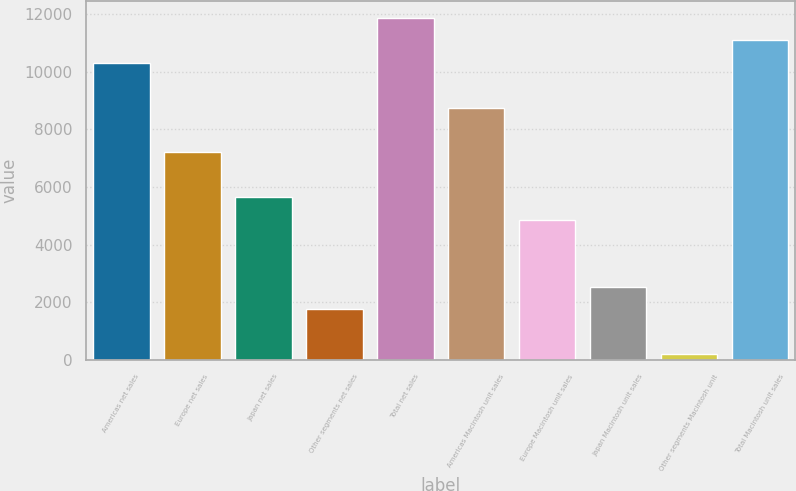<chart> <loc_0><loc_0><loc_500><loc_500><bar_chart><fcel>Americas net sales<fcel>Europe net sales<fcel>Japan net sales<fcel>Other segments net sales<fcel>Total net sales<fcel>Americas Macintosh unit sales<fcel>Europe Macintosh unit sales<fcel>Japan Macintosh unit sales<fcel>Other segments Macintosh unit<fcel>Total Macintosh unit sales<nl><fcel>10314.6<fcel>7205.8<fcel>5651.4<fcel>1765.4<fcel>11869<fcel>8760.2<fcel>4874.2<fcel>2542.6<fcel>211<fcel>11091.8<nl></chart> 